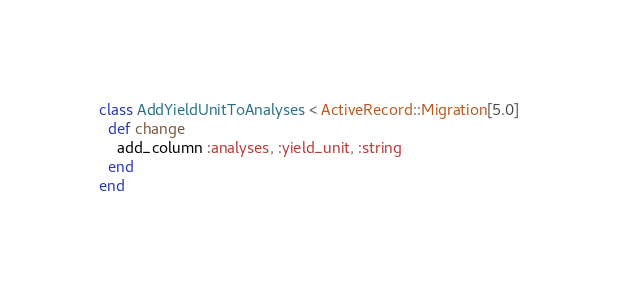<code> <loc_0><loc_0><loc_500><loc_500><_Ruby_>class AddYieldUnitToAnalyses < ActiveRecord::Migration[5.0]
  def change
    add_column :analyses, :yield_unit, :string
  end
end
</code> 